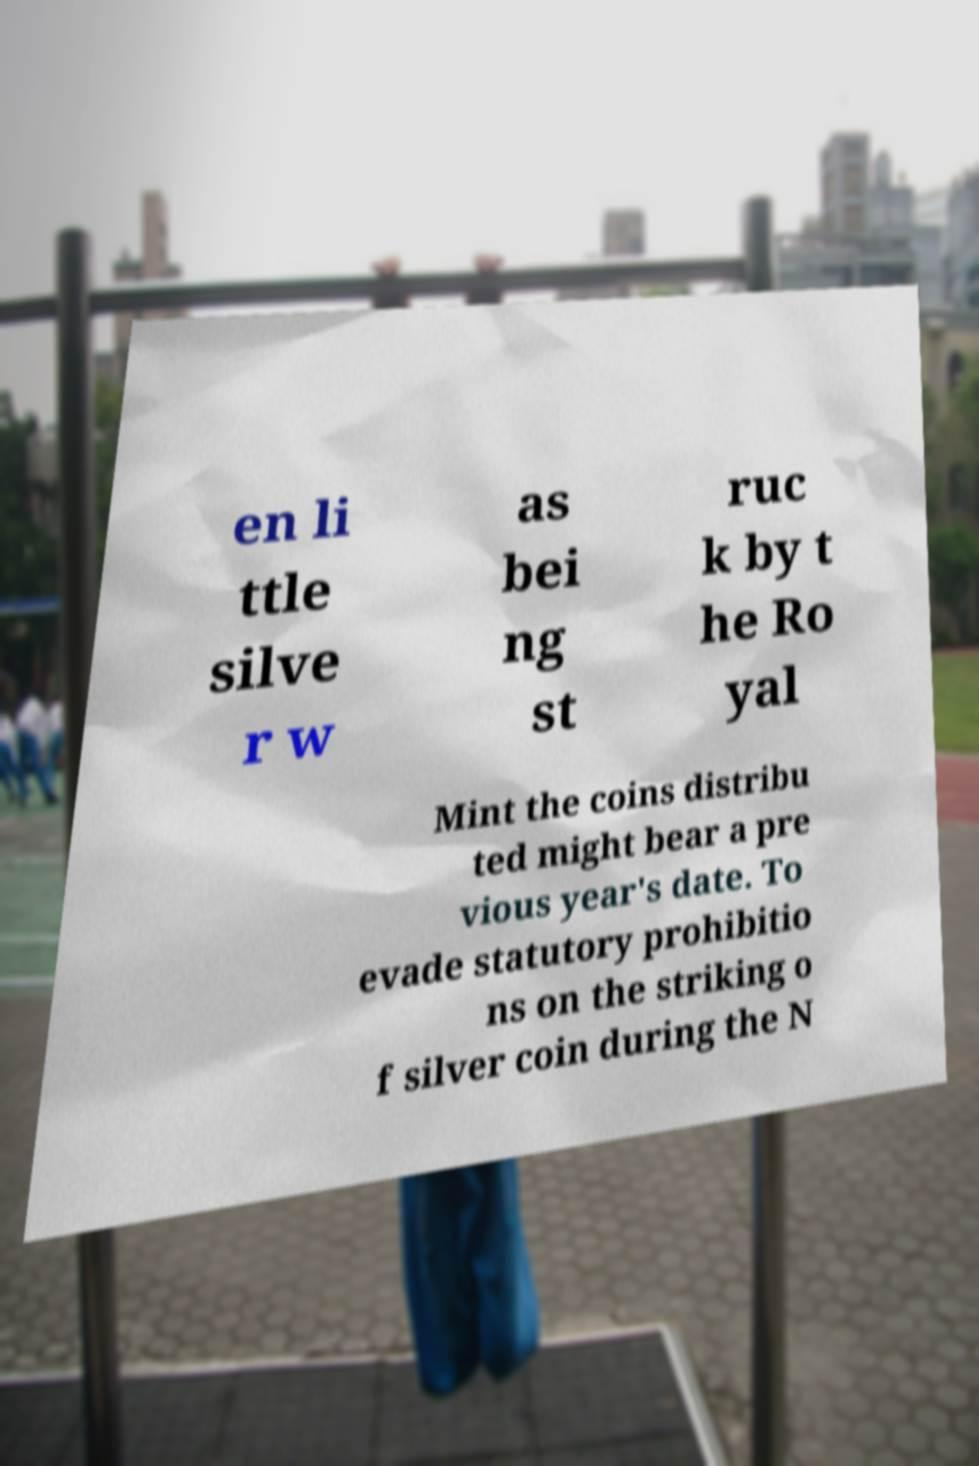Can you read and provide the text displayed in the image?This photo seems to have some interesting text. Can you extract and type it out for me? en li ttle silve r w as bei ng st ruc k by t he Ro yal Mint the coins distribu ted might bear a pre vious year's date. To evade statutory prohibitio ns on the striking o f silver coin during the N 